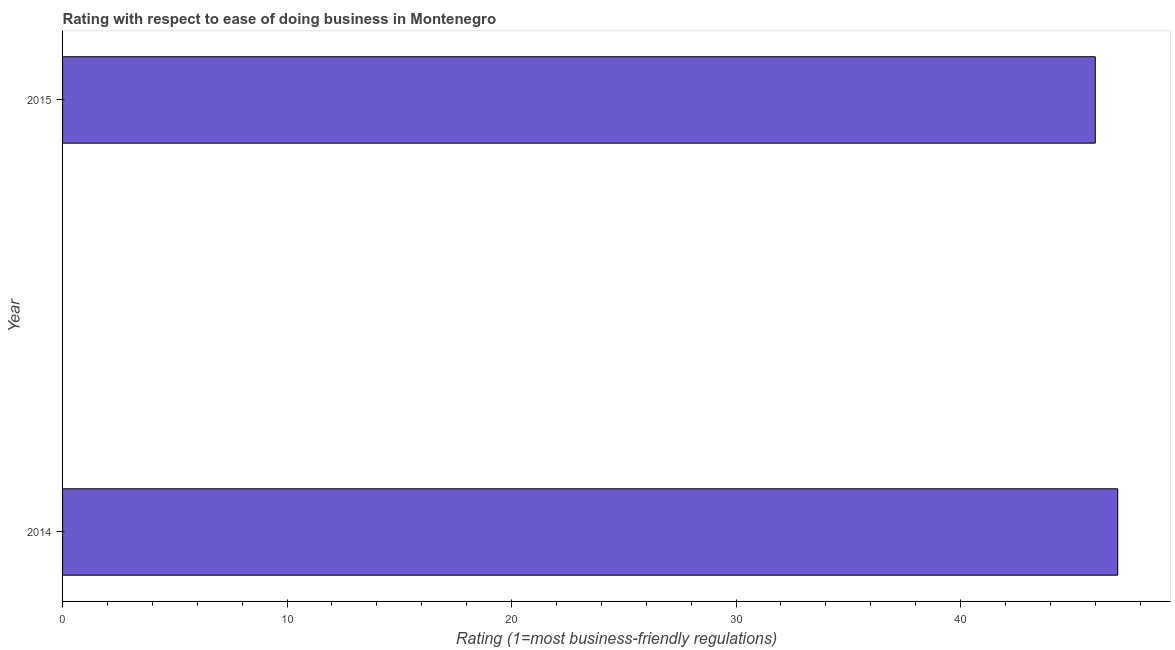What is the title of the graph?
Provide a short and direct response. Rating with respect to ease of doing business in Montenegro. What is the label or title of the X-axis?
Provide a succinct answer. Rating (1=most business-friendly regulations). What is the label or title of the Y-axis?
Your answer should be compact. Year. What is the ease of doing business index in 2014?
Ensure brevity in your answer.  47. In which year was the ease of doing business index maximum?
Your response must be concise. 2014. In which year was the ease of doing business index minimum?
Your answer should be compact. 2015. What is the sum of the ease of doing business index?
Provide a succinct answer. 93. What is the difference between the ease of doing business index in 2014 and 2015?
Offer a terse response. 1. What is the average ease of doing business index per year?
Provide a succinct answer. 46. What is the median ease of doing business index?
Give a very brief answer. 46.5. In how many years, is the ease of doing business index greater than 44 ?
Provide a succinct answer. 2. Do a majority of the years between 2015 and 2014 (inclusive) have ease of doing business index greater than 2 ?
Offer a terse response. No. What is the ratio of the ease of doing business index in 2014 to that in 2015?
Your answer should be very brief. 1.02. Is the ease of doing business index in 2014 less than that in 2015?
Ensure brevity in your answer.  No. In how many years, is the ease of doing business index greater than the average ease of doing business index taken over all years?
Your response must be concise. 1. What is the difference between two consecutive major ticks on the X-axis?
Offer a very short reply. 10. Are the values on the major ticks of X-axis written in scientific E-notation?
Your response must be concise. No. What is the Rating (1=most business-friendly regulations) of 2014?
Offer a terse response. 47. What is the Rating (1=most business-friendly regulations) in 2015?
Offer a very short reply. 46. What is the difference between the Rating (1=most business-friendly regulations) in 2014 and 2015?
Provide a succinct answer. 1. What is the ratio of the Rating (1=most business-friendly regulations) in 2014 to that in 2015?
Ensure brevity in your answer.  1.02. 